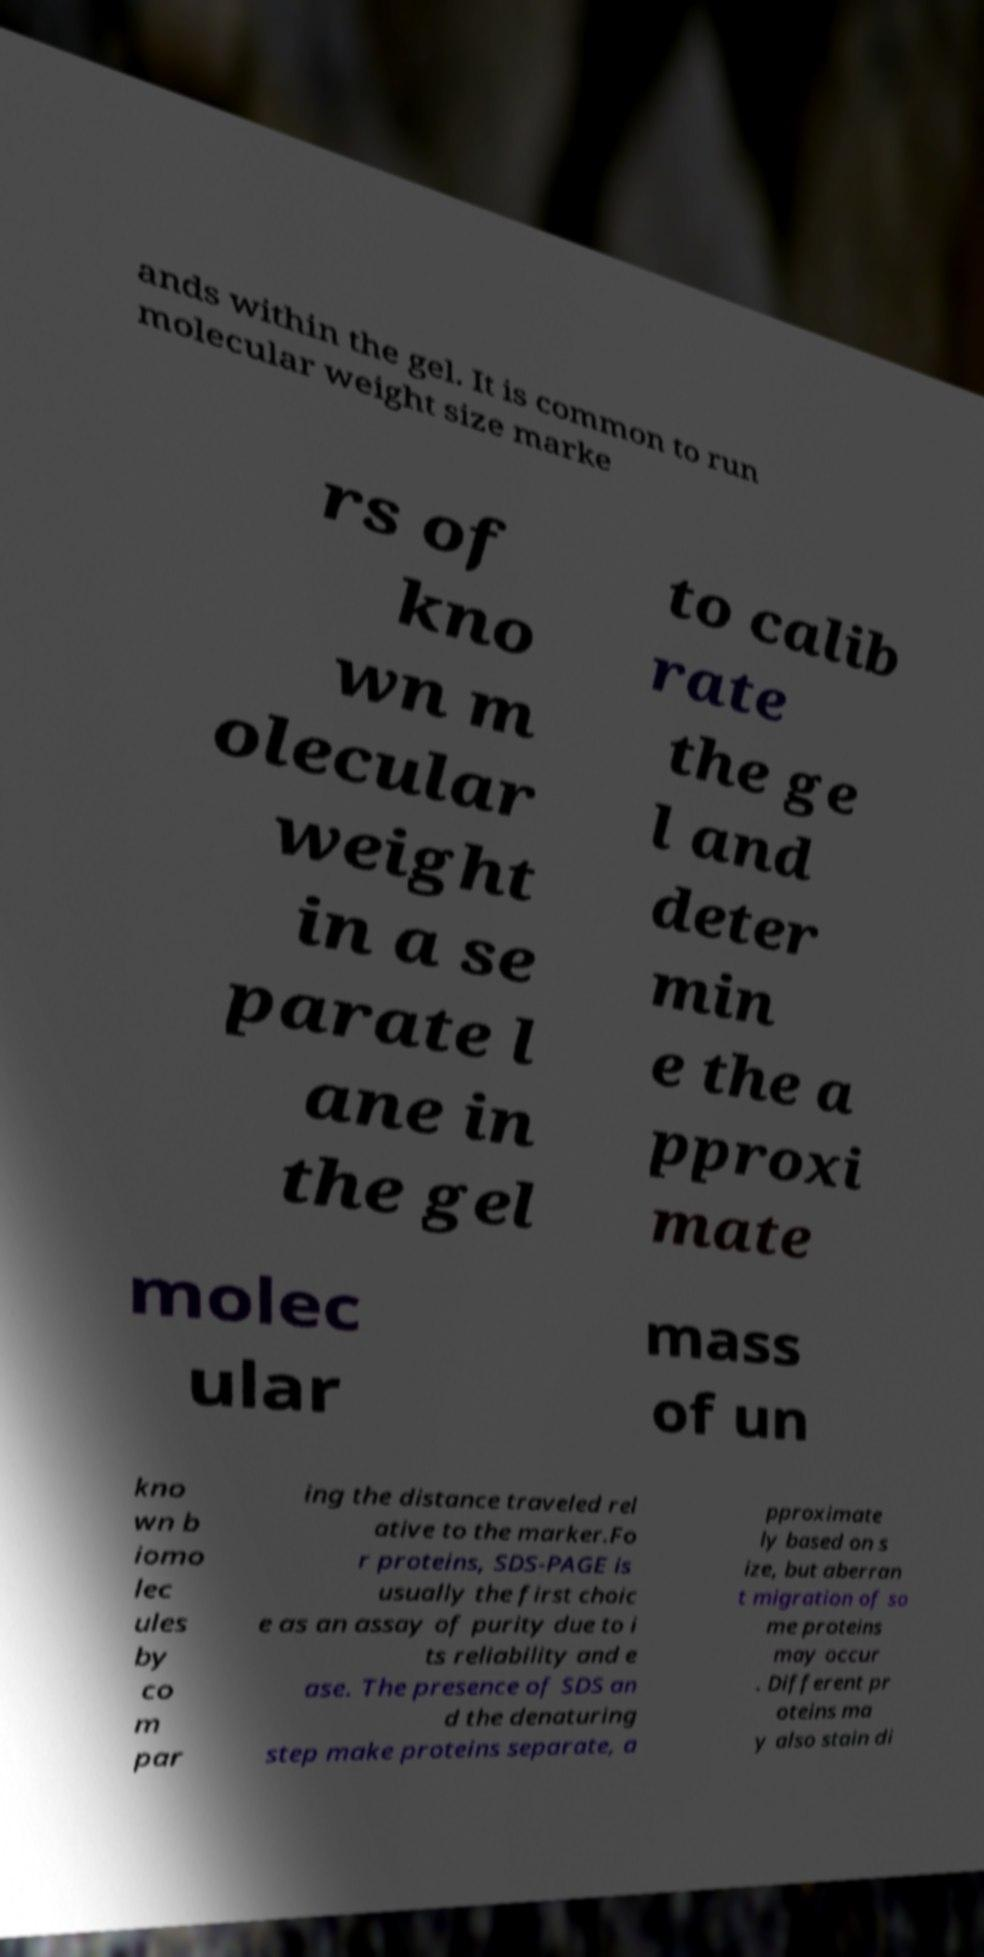Could you assist in decoding the text presented in this image and type it out clearly? ands within the gel. It is common to run molecular weight size marke rs of kno wn m olecular weight in a se parate l ane in the gel to calib rate the ge l and deter min e the a pproxi mate molec ular mass of un kno wn b iomo lec ules by co m par ing the distance traveled rel ative to the marker.Fo r proteins, SDS-PAGE is usually the first choic e as an assay of purity due to i ts reliability and e ase. The presence of SDS an d the denaturing step make proteins separate, a pproximate ly based on s ize, but aberran t migration of so me proteins may occur . Different pr oteins ma y also stain di 